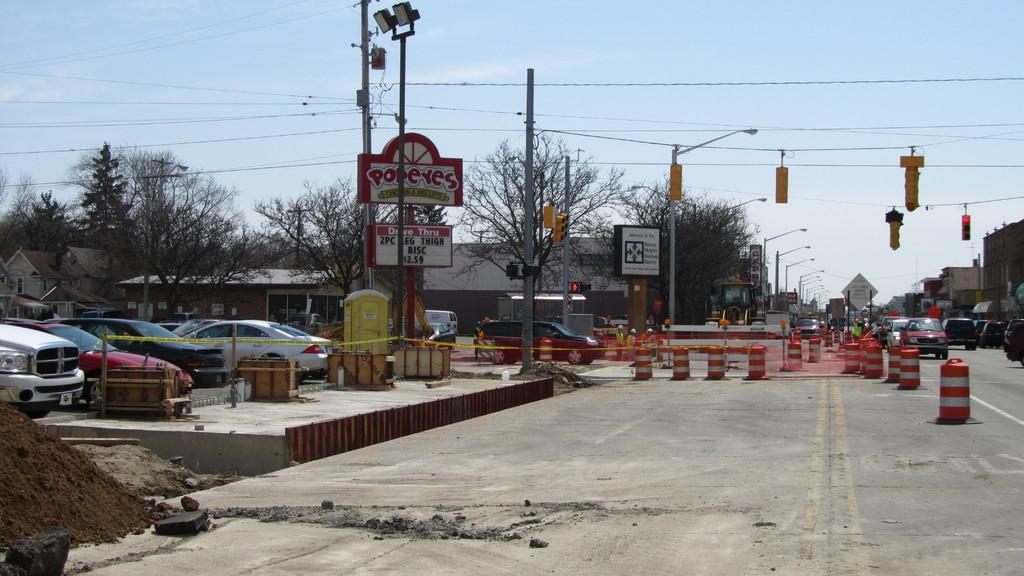<image>
Summarize the visual content of the image. A Popeye's Chicken is surrounded by road construction. 